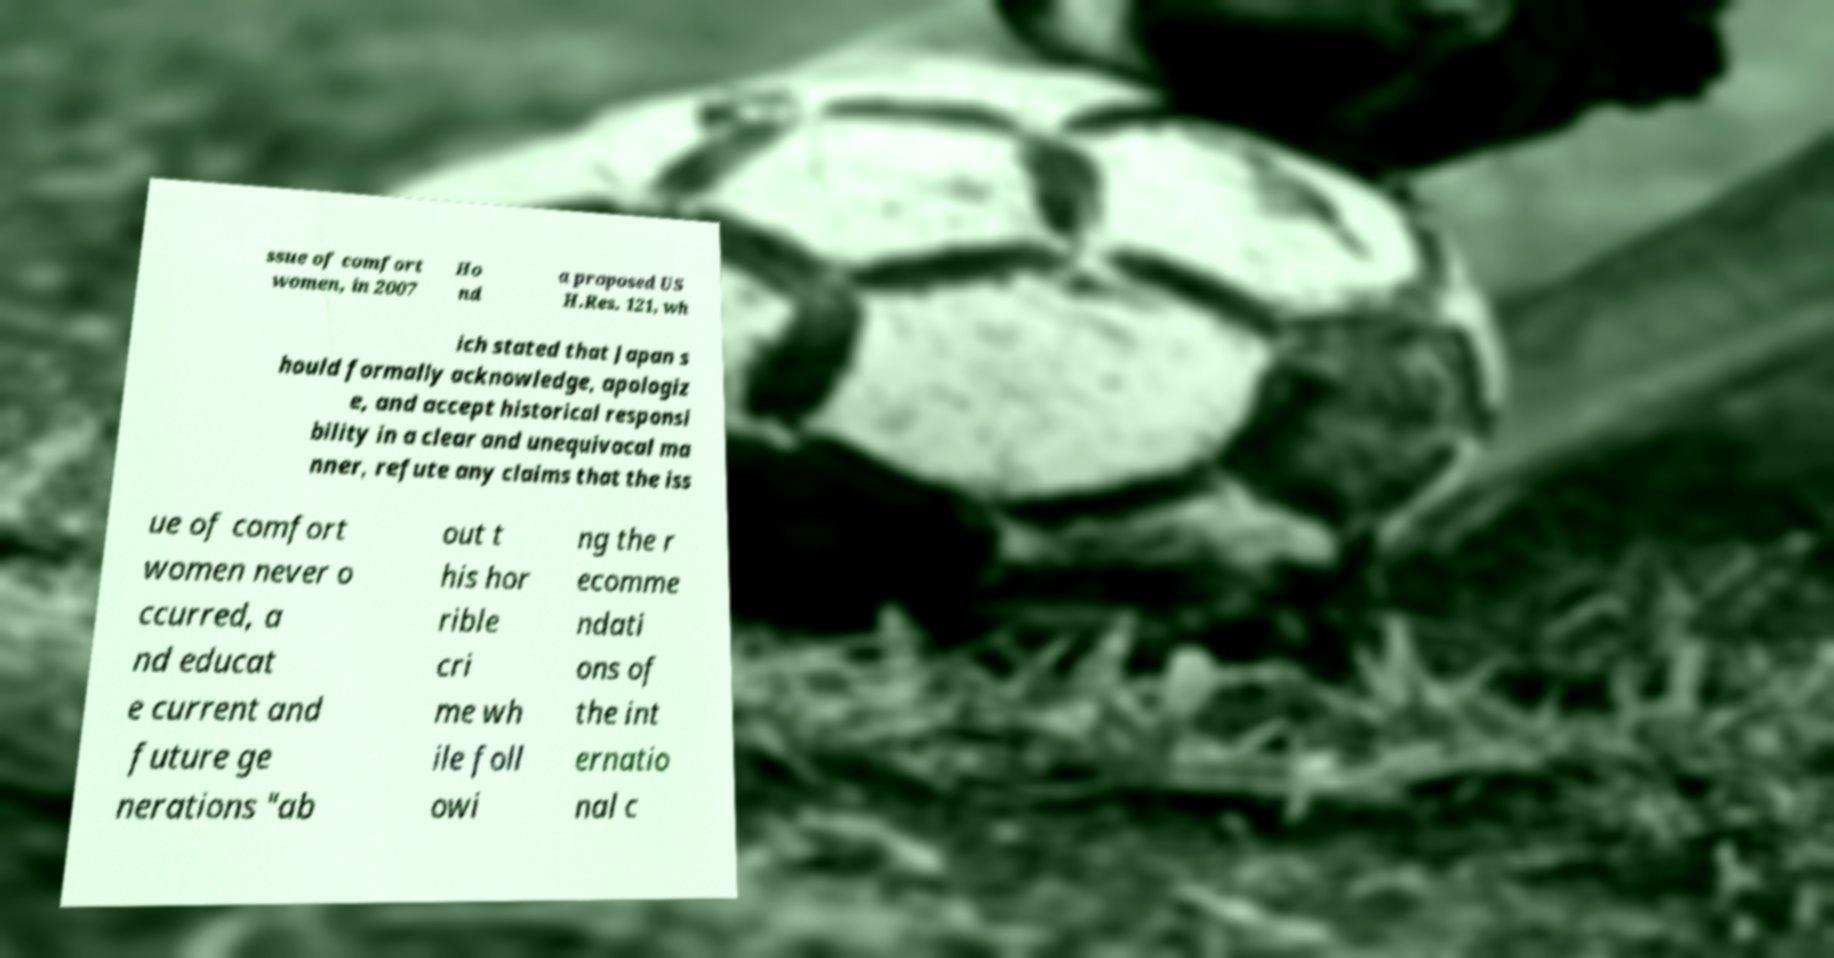Could you assist in decoding the text presented in this image and type it out clearly? ssue of comfort women, in 2007 Ho nd a proposed US H.Res. 121, wh ich stated that Japan s hould formally acknowledge, apologiz e, and accept historical responsi bility in a clear and unequivocal ma nner, refute any claims that the iss ue of comfort women never o ccurred, a nd educat e current and future ge nerations "ab out t his hor rible cri me wh ile foll owi ng the r ecomme ndati ons of the int ernatio nal c 